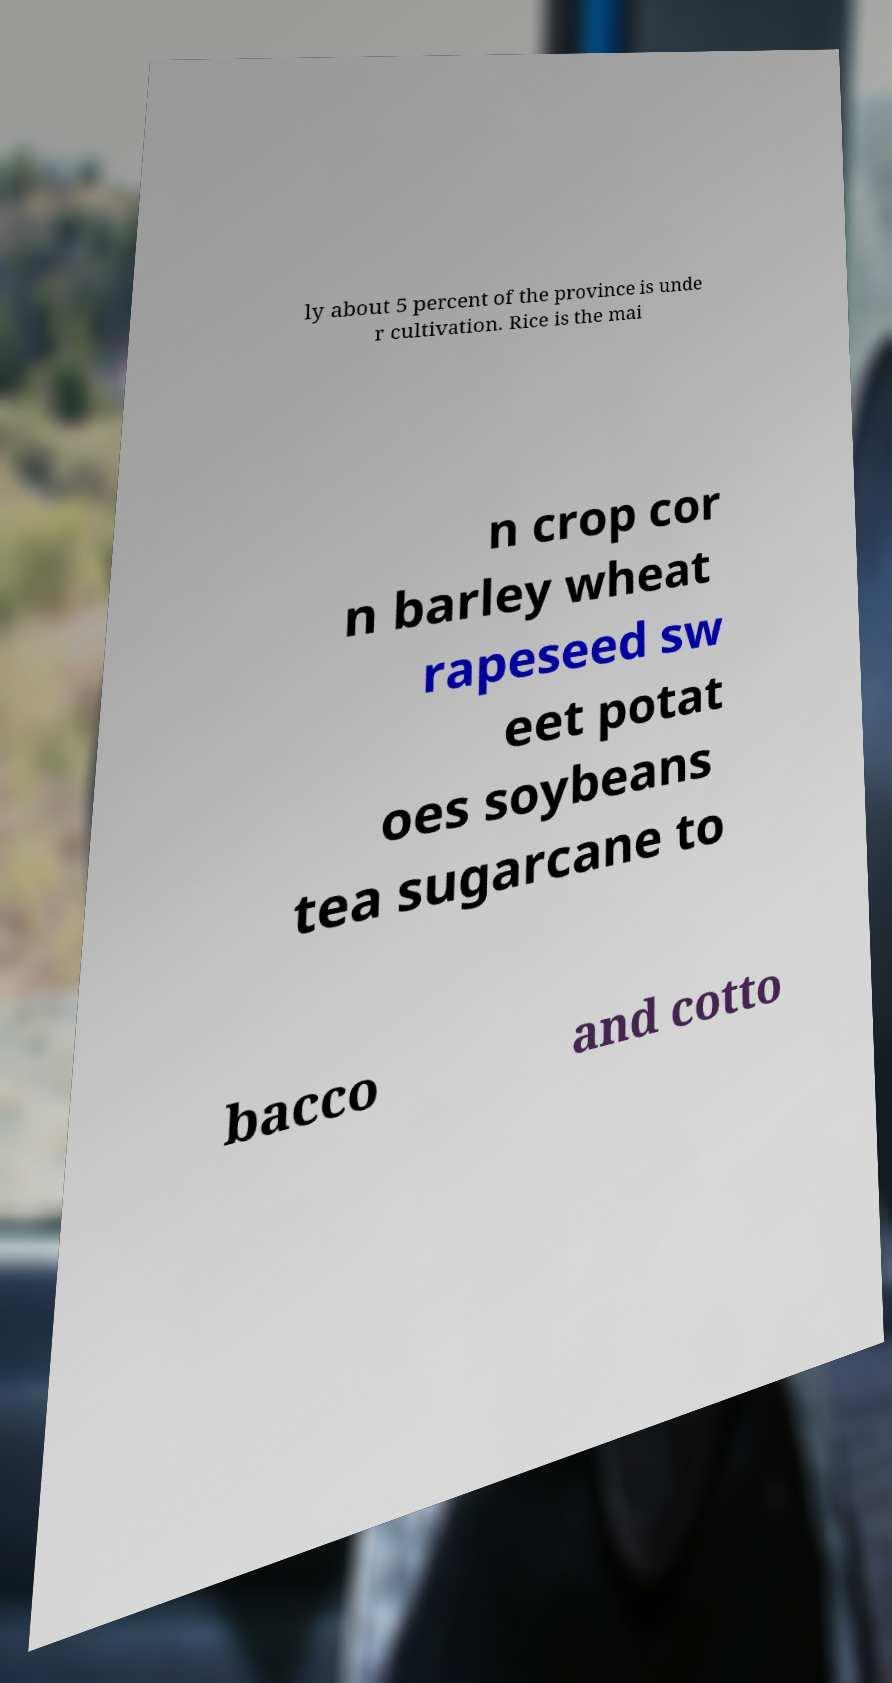There's text embedded in this image that I need extracted. Can you transcribe it verbatim? ly about 5 percent of the province is unde r cultivation. Rice is the mai n crop cor n barley wheat rapeseed sw eet potat oes soybeans tea sugarcane to bacco and cotto 